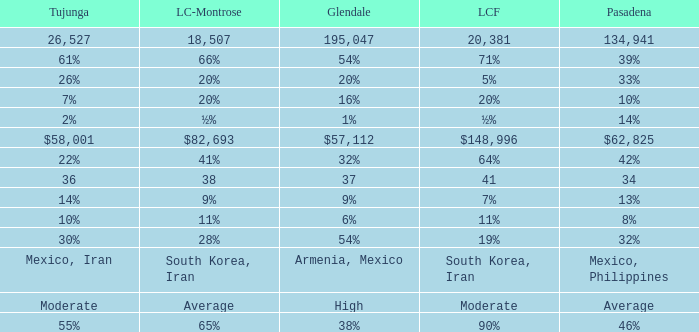When Pasadena is at 10%, what is La Crescenta-Montrose? 20%. 